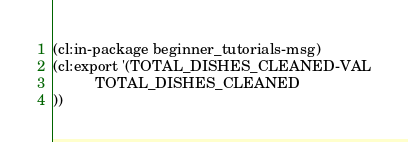Convert code to text. <code><loc_0><loc_0><loc_500><loc_500><_Lisp_>(cl:in-package beginner_tutorials-msg)
(cl:export '(TOTAL_DISHES_CLEANED-VAL
          TOTAL_DISHES_CLEANED
))</code> 